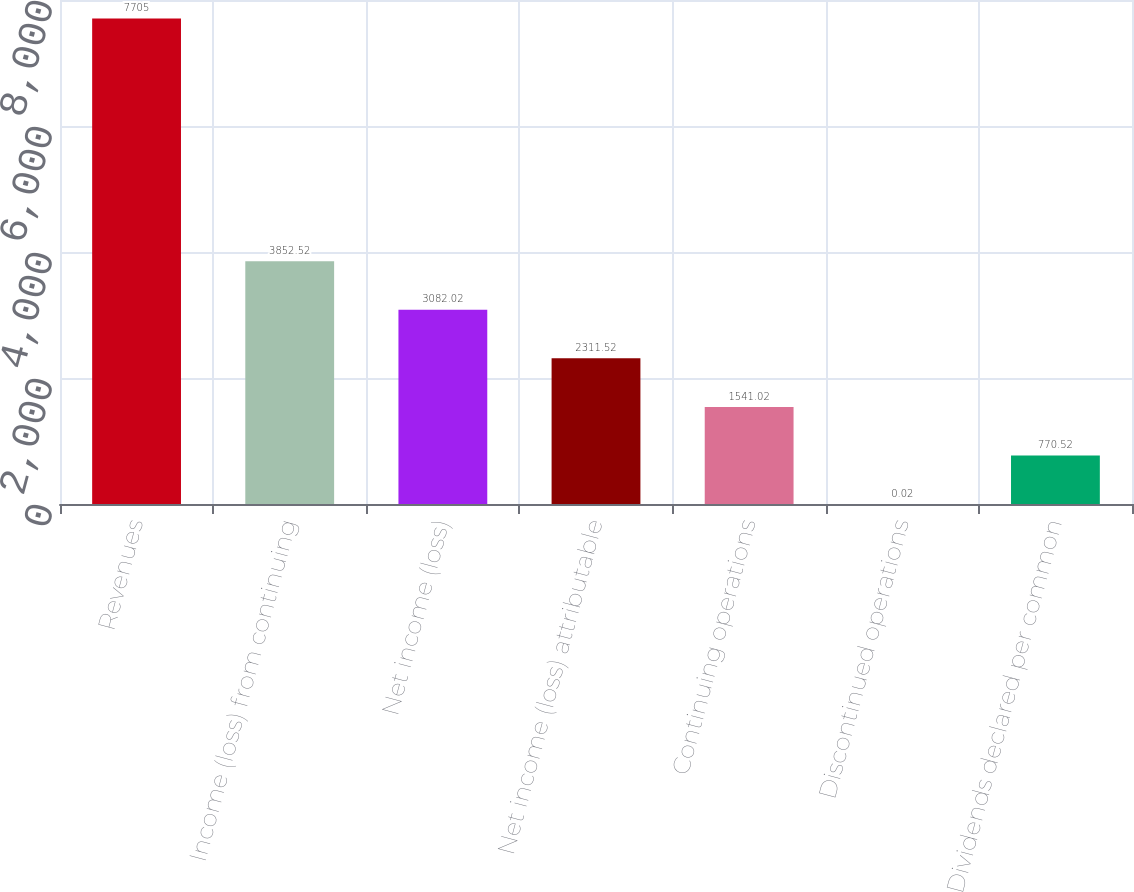<chart> <loc_0><loc_0><loc_500><loc_500><bar_chart><fcel>Revenues<fcel>Income (loss) from continuing<fcel>Net income (loss)<fcel>Net income (loss) attributable<fcel>Continuing operations<fcel>Discontinued operations<fcel>Dividends declared per common<nl><fcel>7705<fcel>3852.52<fcel>3082.02<fcel>2311.52<fcel>1541.02<fcel>0.02<fcel>770.52<nl></chart> 